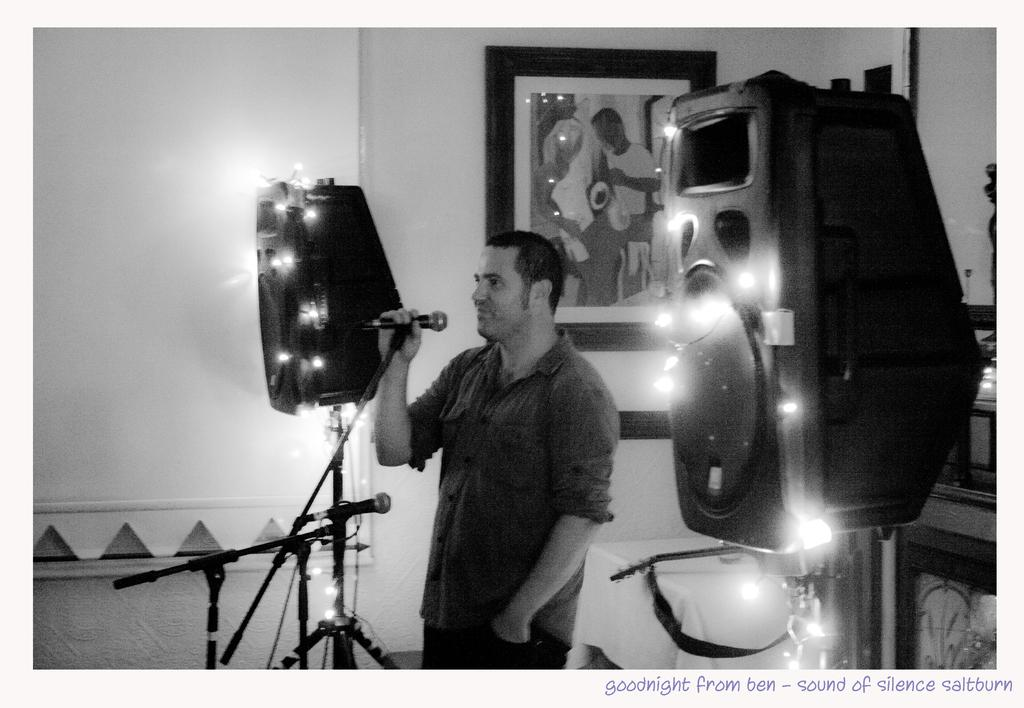What is the person in the image doing? The person is standing in the image and holding a microphone. What objects are present on either side of the person? There are speakers on the left and right sides of the image. What can be seen on the wall in the background of the image? There are photo frames on the wall in the background of the image. What type of hill can be seen in the background of the image? There is no hill present in the image; it is an indoor setting with a person, microphone, speakers, and photo frames on the wall. 